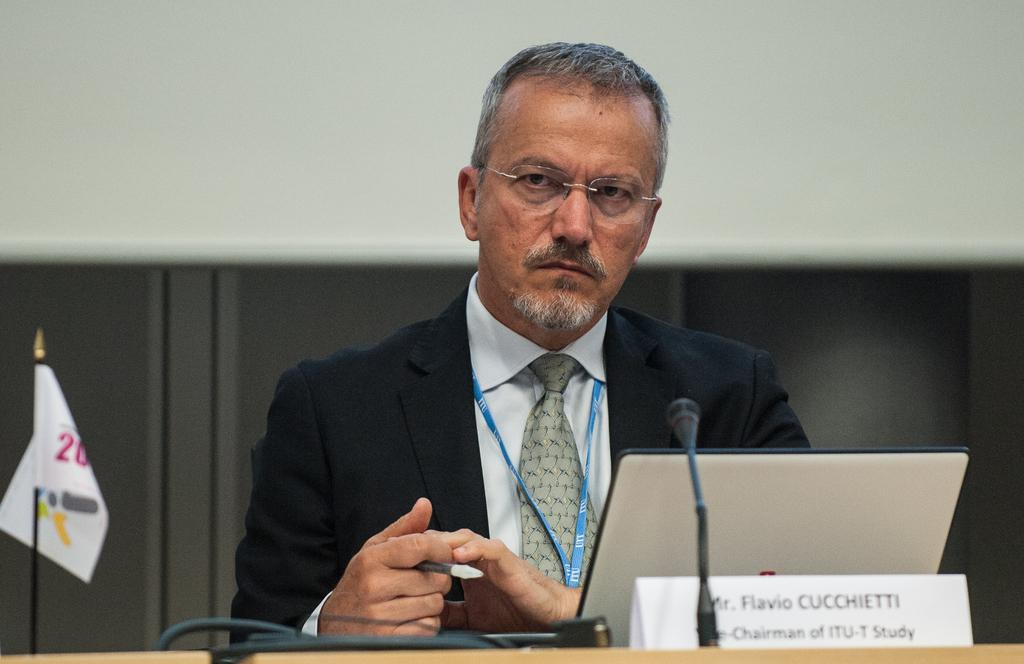Who is present in the image? There is a man in the image. Where is the man located in relation to the table? The man is beside the table. What items can be seen on the table? The table contains a laptop, a microphone, wires, devices, and a name board. What can be seen in the background of the image? There is a flag and a wall visible in the background. What type of act is the man performing in the image? There is no indication of any act being performed in the image; the man is simply standing beside a table. Can you see any smoke in the image? There is no smoke visible in the image. 